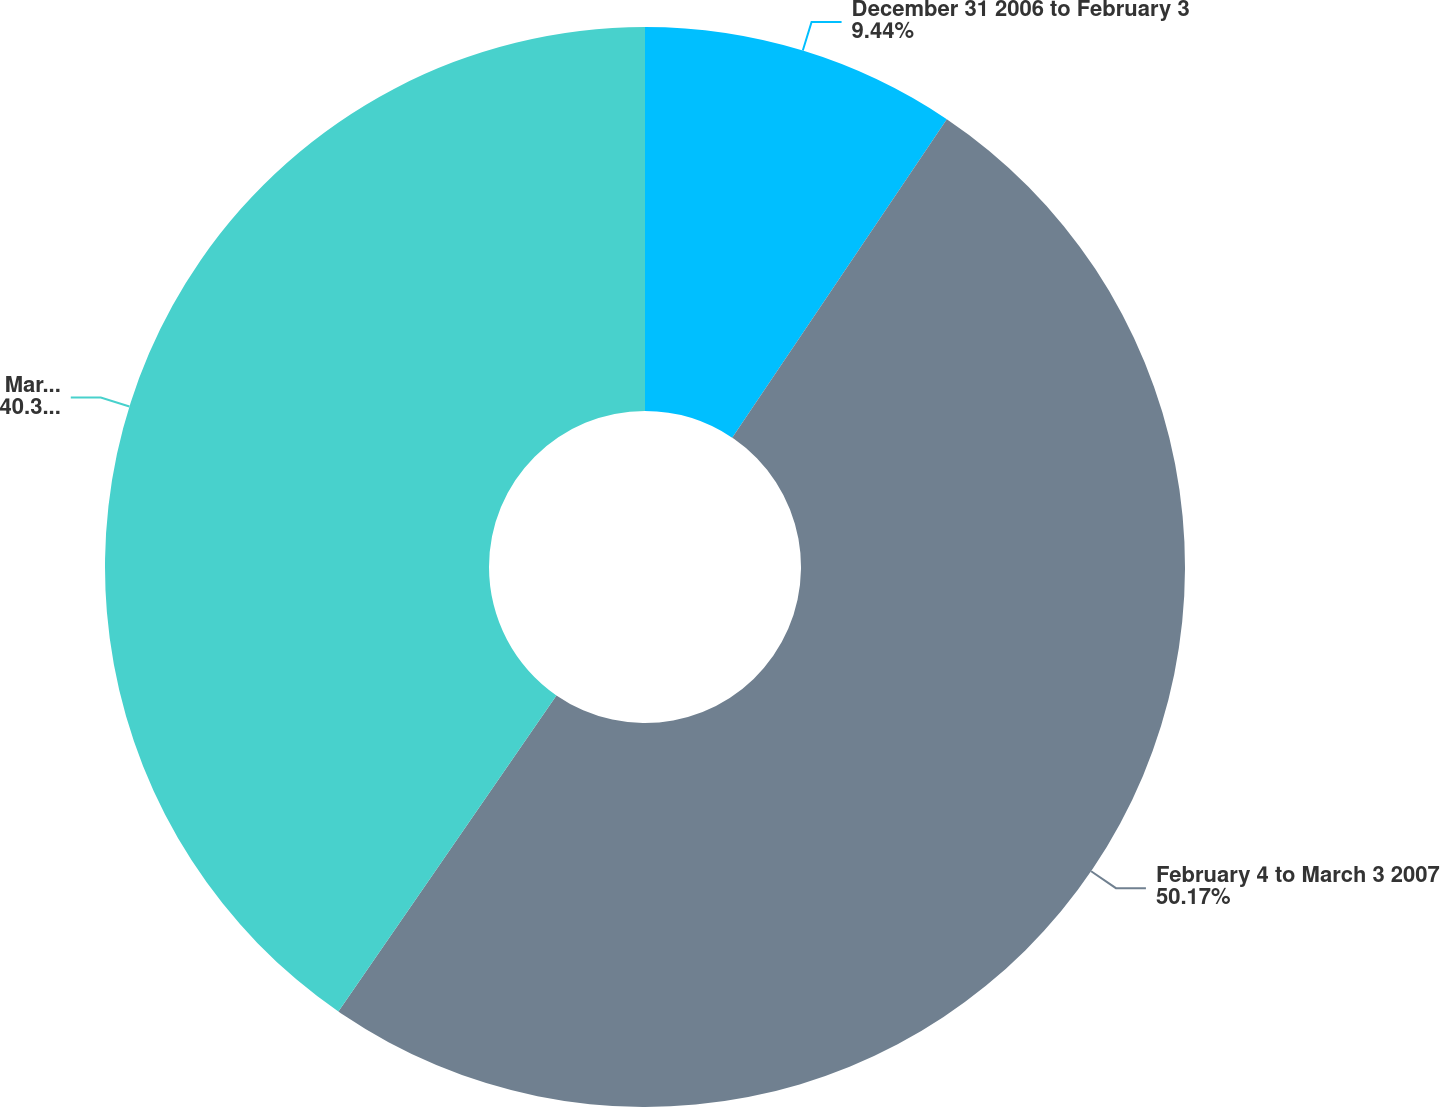<chart> <loc_0><loc_0><loc_500><loc_500><pie_chart><fcel>December 31 2006 to February 3<fcel>February 4 to March 3 2007<fcel>March 4 to March 31 2007<nl><fcel>9.44%<fcel>50.17%<fcel>40.39%<nl></chart> 